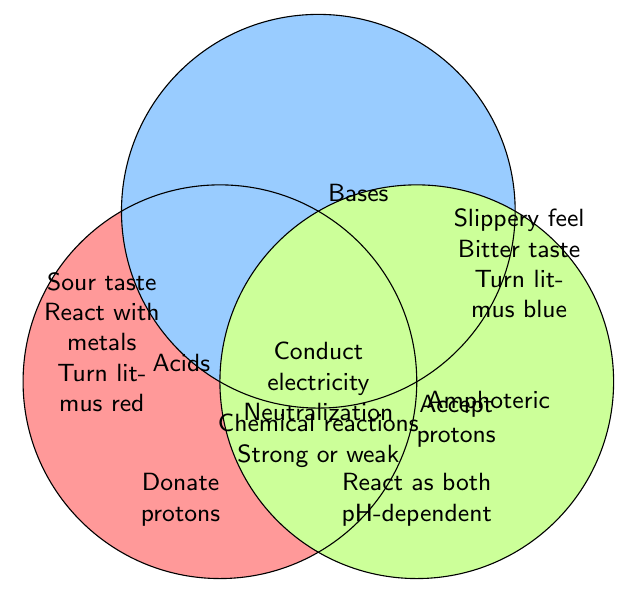What distinctive color is used to represent acids in the figure? The figure uses specific colors to mark different substances. Acids are represented with a unique color. By visually identifying, we find that acids are marked with a light pink color.
Answer: Light pink Which substances participate in chemical reactions according to the figure? A section intersects with all three types, including acids, bases, and amphoteric substances. By locating the intersecting section labeled for chemical reactions at the center of the three circles, we can see it includes acids, bases, and amphoteric substances.
Answer: Acids, Bases, Amphoteric What characteristic is shared by acids and amphoteric substances in the figure? The figure shows an intersection between the circles representing acids and amphoteric substances. We identify the text within this intersecting area, which states "Donate protons."
Answer: Donate protons Do bases conduct electricity in solution according to the diagram? To determine this, we look at the intersection of acids and bases in the Venn diagram. The text within this intersection provides the shared characteristics, including "Conduct electricity in solution."
Answer: Yes How many unique characteristics does the figure assign to acids alone? The yellow region representing acids needs to be examined. This part contains "Sour taste," "React with metals," and "Turn litmus paper red," indicating three unique characteristics.
Answer: Three Which substances can be both strong or weak? The center part of the Venn diagram, which overlaps acids, bases, and amphoteric substances, includes the text "Can be strong or weak," indicating all substance types share this trait.
Answer: Acids, Bases, Amphoteric Name one trait that distinguishes amphoteric substances from acids and bases. We look at unique traits listed solely within the amphoteric circle. Traits include "React as both acid and base" and "pH-dependent behavior." Any one of these is valid.
Answer: React as both acid and base What feature is common between acids and bases referring to pH? The question prompts us to assess the intersection of the circles representing acids and bases. The traits "Conduct electricity in solution" and "Neutralization reactions" are shared, but there is no direct mention of a pH-specific feature being common in this area. Hence, we derive there isn't a shared pH-specific feature shown here.
Answer: None Would you expect acids to turn litmus paper blue? The characteristics within the acid circle indicate "Turn litmus paper red." Since this contradicts blue and only turns red, the concise answer is no.
Answer: No 